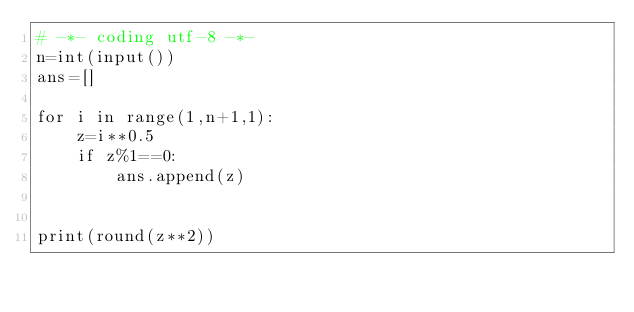<code> <loc_0><loc_0><loc_500><loc_500><_Python_># -*- coding utf-8 -*-
n=int(input())
ans=[]

for i in range(1,n+1,1):
    z=i**0.5
    if z%1==0:
        ans.append(z)


print(round(z**2))
</code> 